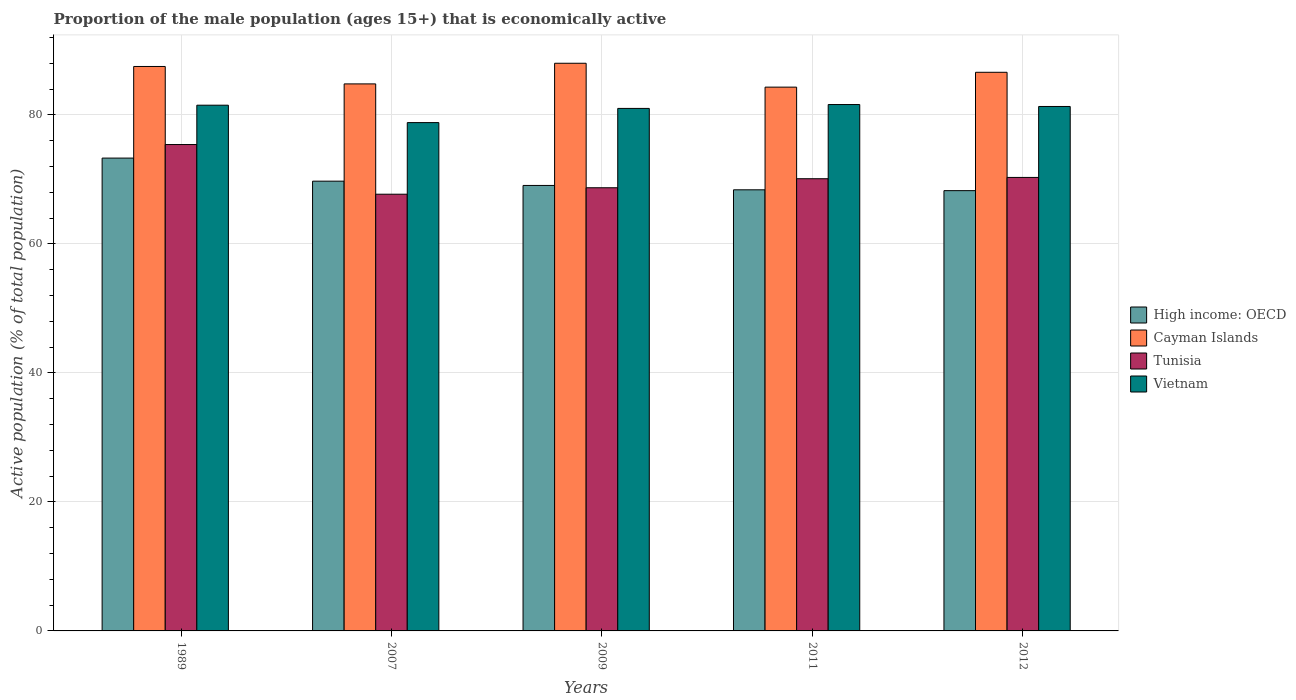Are the number of bars per tick equal to the number of legend labels?
Your response must be concise. Yes. How many bars are there on the 4th tick from the left?
Your answer should be compact. 4. How many bars are there on the 4th tick from the right?
Give a very brief answer. 4. What is the label of the 1st group of bars from the left?
Offer a very short reply. 1989. What is the proportion of the male population that is economically active in Vietnam in 2009?
Your response must be concise. 81. Across all years, what is the maximum proportion of the male population that is economically active in Vietnam?
Provide a succinct answer. 81.6. Across all years, what is the minimum proportion of the male population that is economically active in Tunisia?
Provide a succinct answer. 67.7. In which year was the proportion of the male population that is economically active in Vietnam maximum?
Ensure brevity in your answer.  2011. What is the total proportion of the male population that is economically active in Cayman Islands in the graph?
Keep it short and to the point. 431.2. What is the difference between the proportion of the male population that is economically active in Cayman Islands in 2007 and that in 2011?
Your answer should be compact. 0.5. What is the difference between the proportion of the male population that is economically active in Tunisia in 2011 and the proportion of the male population that is economically active in Vietnam in 2009?
Ensure brevity in your answer.  -10.9. What is the average proportion of the male population that is economically active in Tunisia per year?
Offer a terse response. 70.44. In the year 2012, what is the difference between the proportion of the male population that is economically active in Cayman Islands and proportion of the male population that is economically active in Tunisia?
Your response must be concise. 16.3. In how many years, is the proportion of the male population that is economically active in Vietnam greater than 32 %?
Your answer should be very brief. 5. What is the ratio of the proportion of the male population that is economically active in Cayman Islands in 1989 to that in 2011?
Offer a terse response. 1.04. Is the difference between the proportion of the male population that is economically active in Cayman Islands in 2011 and 2012 greater than the difference between the proportion of the male population that is economically active in Tunisia in 2011 and 2012?
Offer a terse response. No. What is the difference between the highest and the second highest proportion of the male population that is economically active in High income: OECD?
Offer a very short reply. 3.58. What is the difference between the highest and the lowest proportion of the male population that is economically active in Tunisia?
Make the answer very short. 7.7. Is it the case that in every year, the sum of the proportion of the male population that is economically active in High income: OECD and proportion of the male population that is economically active in Tunisia is greater than the sum of proportion of the male population that is economically active in Vietnam and proportion of the male population that is economically active in Cayman Islands?
Offer a very short reply. No. What does the 2nd bar from the left in 2007 represents?
Your answer should be compact. Cayman Islands. What does the 3rd bar from the right in 2012 represents?
Provide a succinct answer. Cayman Islands. Is it the case that in every year, the sum of the proportion of the male population that is economically active in Cayman Islands and proportion of the male population that is economically active in High income: OECD is greater than the proportion of the male population that is economically active in Tunisia?
Offer a terse response. Yes. Are all the bars in the graph horizontal?
Offer a very short reply. No. How many years are there in the graph?
Give a very brief answer. 5. What is the difference between two consecutive major ticks on the Y-axis?
Ensure brevity in your answer.  20. Does the graph contain any zero values?
Ensure brevity in your answer.  No. Where does the legend appear in the graph?
Ensure brevity in your answer.  Center right. How many legend labels are there?
Offer a very short reply. 4. What is the title of the graph?
Keep it short and to the point. Proportion of the male population (ages 15+) that is economically active. Does "Arab World" appear as one of the legend labels in the graph?
Ensure brevity in your answer.  No. What is the label or title of the X-axis?
Offer a terse response. Years. What is the label or title of the Y-axis?
Your response must be concise. Active population (% of total population). What is the Active population (% of total population) in High income: OECD in 1989?
Your answer should be compact. 73.3. What is the Active population (% of total population) in Cayman Islands in 1989?
Give a very brief answer. 87.5. What is the Active population (% of total population) of Tunisia in 1989?
Ensure brevity in your answer.  75.4. What is the Active population (% of total population) of Vietnam in 1989?
Your response must be concise. 81.5. What is the Active population (% of total population) in High income: OECD in 2007?
Ensure brevity in your answer.  69.72. What is the Active population (% of total population) in Cayman Islands in 2007?
Your response must be concise. 84.8. What is the Active population (% of total population) in Tunisia in 2007?
Make the answer very short. 67.7. What is the Active population (% of total population) of Vietnam in 2007?
Your response must be concise. 78.8. What is the Active population (% of total population) in High income: OECD in 2009?
Your answer should be compact. 69.06. What is the Active population (% of total population) of Cayman Islands in 2009?
Your answer should be very brief. 88. What is the Active population (% of total population) in Tunisia in 2009?
Keep it short and to the point. 68.7. What is the Active population (% of total population) of Vietnam in 2009?
Give a very brief answer. 81. What is the Active population (% of total population) of High income: OECD in 2011?
Your response must be concise. 68.38. What is the Active population (% of total population) in Cayman Islands in 2011?
Offer a terse response. 84.3. What is the Active population (% of total population) in Tunisia in 2011?
Provide a short and direct response. 70.1. What is the Active population (% of total population) in Vietnam in 2011?
Give a very brief answer. 81.6. What is the Active population (% of total population) of High income: OECD in 2012?
Offer a terse response. 68.25. What is the Active population (% of total population) in Cayman Islands in 2012?
Your response must be concise. 86.6. What is the Active population (% of total population) of Tunisia in 2012?
Your answer should be very brief. 70.3. What is the Active population (% of total population) in Vietnam in 2012?
Offer a very short reply. 81.3. Across all years, what is the maximum Active population (% of total population) of High income: OECD?
Your response must be concise. 73.3. Across all years, what is the maximum Active population (% of total population) in Tunisia?
Ensure brevity in your answer.  75.4. Across all years, what is the maximum Active population (% of total population) in Vietnam?
Ensure brevity in your answer.  81.6. Across all years, what is the minimum Active population (% of total population) of High income: OECD?
Make the answer very short. 68.25. Across all years, what is the minimum Active population (% of total population) in Cayman Islands?
Offer a very short reply. 84.3. Across all years, what is the minimum Active population (% of total population) of Tunisia?
Ensure brevity in your answer.  67.7. Across all years, what is the minimum Active population (% of total population) in Vietnam?
Ensure brevity in your answer.  78.8. What is the total Active population (% of total population) in High income: OECD in the graph?
Your answer should be compact. 348.71. What is the total Active population (% of total population) of Cayman Islands in the graph?
Ensure brevity in your answer.  431.2. What is the total Active population (% of total population) in Tunisia in the graph?
Ensure brevity in your answer.  352.2. What is the total Active population (% of total population) in Vietnam in the graph?
Ensure brevity in your answer.  404.2. What is the difference between the Active population (% of total population) in High income: OECD in 1989 and that in 2007?
Offer a terse response. 3.58. What is the difference between the Active population (% of total population) of Cayman Islands in 1989 and that in 2007?
Provide a short and direct response. 2.7. What is the difference between the Active population (% of total population) in Tunisia in 1989 and that in 2007?
Provide a short and direct response. 7.7. What is the difference between the Active population (% of total population) in Vietnam in 1989 and that in 2007?
Ensure brevity in your answer.  2.7. What is the difference between the Active population (% of total population) of High income: OECD in 1989 and that in 2009?
Offer a terse response. 4.24. What is the difference between the Active population (% of total population) of Cayman Islands in 1989 and that in 2009?
Ensure brevity in your answer.  -0.5. What is the difference between the Active population (% of total population) in Tunisia in 1989 and that in 2009?
Make the answer very short. 6.7. What is the difference between the Active population (% of total population) in Vietnam in 1989 and that in 2009?
Keep it short and to the point. 0.5. What is the difference between the Active population (% of total population) in High income: OECD in 1989 and that in 2011?
Provide a succinct answer. 4.92. What is the difference between the Active population (% of total population) in Cayman Islands in 1989 and that in 2011?
Offer a terse response. 3.2. What is the difference between the Active population (% of total population) in Tunisia in 1989 and that in 2011?
Your answer should be compact. 5.3. What is the difference between the Active population (% of total population) of High income: OECD in 1989 and that in 2012?
Your response must be concise. 5.05. What is the difference between the Active population (% of total population) in Vietnam in 1989 and that in 2012?
Your response must be concise. 0.2. What is the difference between the Active population (% of total population) in High income: OECD in 2007 and that in 2009?
Provide a succinct answer. 0.66. What is the difference between the Active population (% of total population) in Cayman Islands in 2007 and that in 2009?
Keep it short and to the point. -3.2. What is the difference between the Active population (% of total population) in Vietnam in 2007 and that in 2009?
Provide a short and direct response. -2.2. What is the difference between the Active population (% of total population) of High income: OECD in 2007 and that in 2011?
Make the answer very short. 1.34. What is the difference between the Active population (% of total population) of Cayman Islands in 2007 and that in 2011?
Offer a very short reply. 0.5. What is the difference between the Active population (% of total population) of Vietnam in 2007 and that in 2011?
Make the answer very short. -2.8. What is the difference between the Active population (% of total population) of High income: OECD in 2007 and that in 2012?
Your answer should be compact. 1.47. What is the difference between the Active population (% of total population) in Tunisia in 2007 and that in 2012?
Offer a terse response. -2.6. What is the difference between the Active population (% of total population) of High income: OECD in 2009 and that in 2011?
Offer a very short reply. 0.68. What is the difference between the Active population (% of total population) of Tunisia in 2009 and that in 2011?
Make the answer very short. -1.4. What is the difference between the Active population (% of total population) in High income: OECD in 2009 and that in 2012?
Your response must be concise. 0.81. What is the difference between the Active population (% of total population) in Vietnam in 2009 and that in 2012?
Provide a succinct answer. -0.3. What is the difference between the Active population (% of total population) of High income: OECD in 2011 and that in 2012?
Your answer should be compact. 0.13. What is the difference between the Active population (% of total population) of Tunisia in 2011 and that in 2012?
Provide a short and direct response. -0.2. What is the difference between the Active population (% of total population) in High income: OECD in 1989 and the Active population (% of total population) in Cayman Islands in 2007?
Provide a short and direct response. -11.5. What is the difference between the Active population (% of total population) of High income: OECD in 1989 and the Active population (% of total population) of Tunisia in 2007?
Give a very brief answer. 5.6. What is the difference between the Active population (% of total population) of High income: OECD in 1989 and the Active population (% of total population) of Vietnam in 2007?
Your answer should be compact. -5.5. What is the difference between the Active population (% of total population) in Cayman Islands in 1989 and the Active population (% of total population) in Tunisia in 2007?
Provide a succinct answer. 19.8. What is the difference between the Active population (% of total population) of High income: OECD in 1989 and the Active population (% of total population) of Cayman Islands in 2009?
Offer a terse response. -14.7. What is the difference between the Active population (% of total population) of High income: OECD in 1989 and the Active population (% of total population) of Tunisia in 2009?
Keep it short and to the point. 4.6. What is the difference between the Active population (% of total population) of High income: OECD in 1989 and the Active population (% of total population) of Vietnam in 2009?
Your response must be concise. -7.7. What is the difference between the Active population (% of total population) in Cayman Islands in 1989 and the Active population (% of total population) in Tunisia in 2009?
Your answer should be very brief. 18.8. What is the difference between the Active population (% of total population) in High income: OECD in 1989 and the Active population (% of total population) in Cayman Islands in 2011?
Provide a succinct answer. -11. What is the difference between the Active population (% of total population) of High income: OECD in 1989 and the Active population (% of total population) of Tunisia in 2011?
Keep it short and to the point. 3.2. What is the difference between the Active population (% of total population) in High income: OECD in 1989 and the Active population (% of total population) in Vietnam in 2011?
Ensure brevity in your answer.  -8.3. What is the difference between the Active population (% of total population) in Cayman Islands in 1989 and the Active population (% of total population) in Tunisia in 2011?
Offer a very short reply. 17.4. What is the difference between the Active population (% of total population) in Cayman Islands in 1989 and the Active population (% of total population) in Vietnam in 2011?
Make the answer very short. 5.9. What is the difference between the Active population (% of total population) of Tunisia in 1989 and the Active population (% of total population) of Vietnam in 2011?
Your answer should be compact. -6.2. What is the difference between the Active population (% of total population) in High income: OECD in 1989 and the Active population (% of total population) in Cayman Islands in 2012?
Ensure brevity in your answer.  -13.3. What is the difference between the Active population (% of total population) in High income: OECD in 1989 and the Active population (% of total population) in Tunisia in 2012?
Give a very brief answer. 3. What is the difference between the Active population (% of total population) in High income: OECD in 1989 and the Active population (% of total population) in Vietnam in 2012?
Make the answer very short. -8. What is the difference between the Active population (% of total population) in Cayman Islands in 1989 and the Active population (% of total population) in Tunisia in 2012?
Offer a very short reply. 17.2. What is the difference between the Active population (% of total population) of Tunisia in 1989 and the Active population (% of total population) of Vietnam in 2012?
Provide a succinct answer. -5.9. What is the difference between the Active population (% of total population) in High income: OECD in 2007 and the Active population (% of total population) in Cayman Islands in 2009?
Give a very brief answer. -18.28. What is the difference between the Active population (% of total population) in High income: OECD in 2007 and the Active population (% of total population) in Tunisia in 2009?
Offer a terse response. 1.02. What is the difference between the Active population (% of total population) of High income: OECD in 2007 and the Active population (% of total population) of Vietnam in 2009?
Give a very brief answer. -11.28. What is the difference between the Active population (% of total population) in Cayman Islands in 2007 and the Active population (% of total population) in Tunisia in 2009?
Offer a very short reply. 16.1. What is the difference between the Active population (% of total population) of High income: OECD in 2007 and the Active population (% of total population) of Cayman Islands in 2011?
Your response must be concise. -14.58. What is the difference between the Active population (% of total population) of High income: OECD in 2007 and the Active population (% of total population) of Tunisia in 2011?
Offer a very short reply. -0.38. What is the difference between the Active population (% of total population) in High income: OECD in 2007 and the Active population (% of total population) in Vietnam in 2011?
Ensure brevity in your answer.  -11.88. What is the difference between the Active population (% of total population) in Cayman Islands in 2007 and the Active population (% of total population) in Tunisia in 2011?
Your answer should be very brief. 14.7. What is the difference between the Active population (% of total population) of Tunisia in 2007 and the Active population (% of total population) of Vietnam in 2011?
Your answer should be compact. -13.9. What is the difference between the Active population (% of total population) in High income: OECD in 2007 and the Active population (% of total population) in Cayman Islands in 2012?
Keep it short and to the point. -16.88. What is the difference between the Active population (% of total population) of High income: OECD in 2007 and the Active population (% of total population) of Tunisia in 2012?
Keep it short and to the point. -0.58. What is the difference between the Active population (% of total population) in High income: OECD in 2007 and the Active population (% of total population) in Vietnam in 2012?
Keep it short and to the point. -11.58. What is the difference between the Active population (% of total population) of Cayman Islands in 2007 and the Active population (% of total population) of Tunisia in 2012?
Offer a terse response. 14.5. What is the difference between the Active population (% of total population) of Tunisia in 2007 and the Active population (% of total population) of Vietnam in 2012?
Ensure brevity in your answer.  -13.6. What is the difference between the Active population (% of total population) in High income: OECD in 2009 and the Active population (% of total population) in Cayman Islands in 2011?
Keep it short and to the point. -15.24. What is the difference between the Active population (% of total population) in High income: OECD in 2009 and the Active population (% of total population) in Tunisia in 2011?
Give a very brief answer. -1.04. What is the difference between the Active population (% of total population) in High income: OECD in 2009 and the Active population (% of total population) in Vietnam in 2011?
Your answer should be compact. -12.54. What is the difference between the Active population (% of total population) of Cayman Islands in 2009 and the Active population (% of total population) of Tunisia in 2011?
Offer a terse response. 17.9. What is the difference between the Active population (% of total population) of Cayman Islands in 2009 and the Active population (% of total population) of Vietnam in 2011?
Offer a very short reply. 6.4. What is the difference between the Active population (% of total population) of High income: OECD in 2009 and the Active population (% of total population) of Cayman Islands in 2012?
Offer a terse response. -17.54. What is the difference between the Active population (% of total population) of High income: OECD in 2009 and the Active population (% of total population) of Tunisia in 2012?
Keep it short and to the point. -1.24. What is the difference between the Active population (% of total population) in High income: OECD in 2009 and the Active population (% of total population) in Vietnam in 2012?
Provide a succinct answer. -12.24. What is the difference between the Active population (% of total population) in Cayman Islands in 2009 and the Active population (% of total population) in Tunisia in 2012?
Your response must be concise. 17.7. What is the difference between the Active population (% of total population) in Cayman Islands in 2009 and the Active population (% of total population) in Vietnam in 2012?
Offer a terse response. 6.7. What is the difference between the Active population (% of total population) in High income: OECD in 2011 and the Active population (% of total population) in Cayman Islands in 2012?
Offer a terse response. -18.22. What is the difference between the Active population (% of total population) in High income: OECD in 2011 and the Active population (% of total population) in Tunisia in 2012?
Make the answer very short. -1.92. What is the difference between the Active population (% of total population) in High income: OECD in 2011 and the Active population (% of total population) in Vietnam in 2012?
Give a very brief answer. -12.92. What is the difference between the Active population (% of total population) of Cayman Islands in 2011 and the Active population (% of total population) of Tunisia in 2012?
Ensure brevity in your answer.  14. What is the difference between the Active population (% of total population) of Tunisia in 2011 and the Active population (% of total population) of Vietnam in 2012?
Make the answer very short. -11.2. What is the average Active population (% of total population) in High income: OECD per year?
Provide a short and direct response. 69.74. What is the average Active population (% of total population) of Cayman Islands per year?
Offer a very short reply. 86.24. What is the average Active population (% of total population) of Tunisia per year?
Provide a succinct answer. 70.44. What is the average Active population (% of total population) of Vietnam per year?
Your answer should be very brief. 80.84. In the year 1989, what is the difference between the Active population (% of total population) in High income: OECD and Active population (% of total population) in Cayman Islands?
Your answer should be compact. -14.2. In the year 1989, what is the difference between the Active population (% of total population) in High income: OECD and Active population (% of total population) in Tunisia?
Your answer should be very brief. -2.1. In the year 1989, what is the difference between the Active population (% of total population) in High income: OECD and Active population (% of total population) in Vietnam?
Keep it short and to the point. -8.2. In the year 2007, what is the difference between the Active population (% of total population) of High income: OECD and Active population (% of total population) of Cayman Islands?
Your answer should be very brief. -15.08. In the year 2007, what is the difference between the Active population (% of total population) of High income: OECD and Active population (% of total population) of Tunisia?
Make the answer very short. 2.02. In the year 2007, what is the difference between the Active population (% of total population) in High income: OECD and Active population (% of total population) in Vietnam?
Keep it short and to the point. -9.08. In the year 2009, what is the difference between the Active population (% of total population) of High income: OECD and Active population (% of total population) of Cayman Islands?
Keep it short and to the point. -18.94. In the year 2009, what is the difference between the Active population (% of total population) of High income: OECD and Active population (% of total population) of Tunisia?
Give a very brief answer. 0.36. In the year 2009, what is the difference between the Active population (% of total population) of High income: OECD and Active population (% of total population) of Vietnam?
Your response must be concise. -11.94. In the year 2009, what is the difference between the Active population (% of total population) of Cayman Islands and Active population (% of total population) of Tunisia?
Your answer should be very brief. 19.3. In the year 2009, what is the difference between the Active population (% of total population) of Cayman Islands and Active population (% of total population) of Vietnam?
Keep it short and to the point. 7. In the year 2011, what is the difference between the Active population (% of total population) in High income: OECD and Active population (% of total population) in Cayman Islands?
Offer a very short reply. -15.92. In the year 2011, what is the difference between the Active population (% of total population) of High income: OECD and Active population (% of total population) of Tunisia?
Provide a short and direct response. -1.72. In the year 2011, what is the difference between the Active population (% of total population) of High income: OECD and Active population (% of total population) of Vietnam?
Your answer should be very brief. -13.22. In the year 2011, what is the difference between the Active population (% of total population) of Cayman Islands and Active population (% of total population) of Vietnam?
Ensure brevity in your answer.  2.7. In the year 2011, what is the difference between the Active population (% of total population) in Tunisia and Active population (% of total population) in Vietnam?
Offer a terse response. -11.5. In the year 2012, what is the difference between the Active population (% of total population) of High income: OECD and Active population (% of total population) of Cayman Islands?
Your answer should be compact. -18.35. In the year 2012, what is the difference between the Active population (% of total population) in High income: OECD and Active population (% of total population) in Tunisia?
Your answer should be very brief. -2.05. In the year 2012, what is the difference between the Active population (% of total population) in High income: OECD and Active population (% of total population) in Vietnam?
Offer a terse response. -13.05. In the year 2012, what is the difference between the Active population (% of total population) of Cayman Islands and Active population (% of total population) of Vietnam?
Offer a very short reply. 5.3. What is the ratio of the Active population (% of total population) in High income: OECD in 1989 to that in 2007?
Ensure brevity in your answer.  1.05. What is the ratio of the Active population (% of total population) in Cayman Islands in 1989 to that in 2007?
Offer a terse response. 1.03. What is the ratio of the Active population (% of total population) in Tunisia in 1989 to that in 2007?
Your response must be concise. 1.11. What is the ratio of the Active population (% of total population) of Vietnam in 1989 to that in 2007?
Ensure brevity in your answer.  1.03. What is the ratio of the Active population (% of total population) of High income: OECD in 1989 to that in 2009?
Your answer should be compact. 1.06. What is the ratio of the Active population (% of total population) in Tunisia in 1989 to that in 2009?
Your answer should be very brief. 1.1. What is the ratio of the Active population (% of total population) in High income: OECD in 1989 to that in 2011?
Your response must be concise. 1.07. What is the ratio of the Active population (% of total population) of Cayman Islands in 1989 to that in 2011?
Make the answer very short. 1.04. What is the ratio of the Active population (% of total population) of Tunisia in 1989 to that in 2011?
Your answer should be very brief. 1.08. What is the ratio of the Active population (% of total population) of High income: OECD in 1989 to that in 2012?
Keep it short and to the point. 1.07. What is the ratio of the Active population (% of total population) in Cayman Islands in 1989 to that in 2012?
Keep it short and to the point. 1.01. What is the ratio of the Active population (% of total population) of Tunisia in 1989 to that in 2012?
Ensure brevity in your answer.  1.07. What is the ratio of the Active population (% of total population) in Vietnam in 1989 to that in 2012?
Provide a short and direct response. 1. What is the ratio of the Active population (% of total population) in High income: OECD in 2007 to that in 2009?
Ensure brevity in your answer.  1.01. What is the ratio of the Active population (% of total population) in Cayman Islands in 2007 to that in 2009?
Offer a terse response. 0.96. What is the ratio of the Active population (% of total population) of Tunisia in 2007 to that in 2009?
Your answer should be compact. 0.99. What is the ratio of the Active population (% of total population) in Vietnam in 2007 to that in 2009?
Offer a very short reply. 0.97. What is the ratio of the Active population (% of total population) in High income: OECD in 2007 to that in 2011?
Make the answer very short. 1.02. What is the ratio of the Active population (% of total population) of Cayman Islands in 2007 to that in 2011?
Offer a very short reply. 1.01. What is the ratio of the Active population (% of total population) in Tunisia in 2007 to that in 2011?
Make the answer very short. 0.97. What is the ratio of the Active population (% of total population) in Vietnam in 2007 to that in 2011?
Your response must be concise. 0.97. What is the ratio of the Active population (% of total population) in High income: OECD in 2007 to that in 2012?
Keep it short and to the point. 1.02. What is the ratio of the Active population (% of total population) of Cayman Islands in 2007 to that in 2012?
Keep it short and to the point. 0.98. What is the ratio of the Active population (% of total population) of Vietnam in 2007 to that in 2012?
Provide a short and direct response. 0.97. What is the ratio of the Active population (% of total population) in High income: OECD in 2009 to that in 2011?
Provide a short and direct response. 1.01. What is the ratio of the Active population (% of total population) of Cayman Islands in 2009 to that in 2011?
Make the answer very short. 1.04. What is the ratio of the Active population (% of total population) in Tunisia in 2009 to that in 2011?
Ensure brevity in your answer.  0.98. What is the ratio of the Active population (% of total population) of High income: OECD in 2009 to that in 2012?
Offer a very short reply. 1.01. What is the ratio of the Active population (% of total population) of Cayman Islands in 2009 to that in 2012?
Provide a succinct answer. 1.02. What is the ratio of the Active population (% of total population) of Tunisia in 2009 to that in 2012?
Ensure brevity in your answer.  0.98. What is the ratio of the Active population (% of total population) in High income: OECD in 2011 to that in 2012?
Your response must be concise. 1. What is the ratio of the Active population (% of total population) of Cayman Islands in 2011 to that in 2012?
Provide a short and direct response. 0.97. What is the ratio of the Active population (% of total population) in Vietnam in 2011 to that in 2012?
Offer a terse response. 1. What is the difference between the highest and the second highest Active population (% of total population) in High income: OECD?
Provide a short and direct response. 3.58. What is the difference between the highest and the second highest Active population (% of total population) of Tunisia?
Keep it short and to the point. 5.1. What is the difference between the highest and the lowest Active population (% of total population) of High income: OECD?
Provide a succinct answer. 5.05. What is the difference between the highest and the lowest Active population (% of total population) of Cayman Islands?
Make the answer very short. 3.7. What is the difference between the highest and the lowest Active population (% of total population) in Vietnam?
Give a very brief answer. 2.8. 